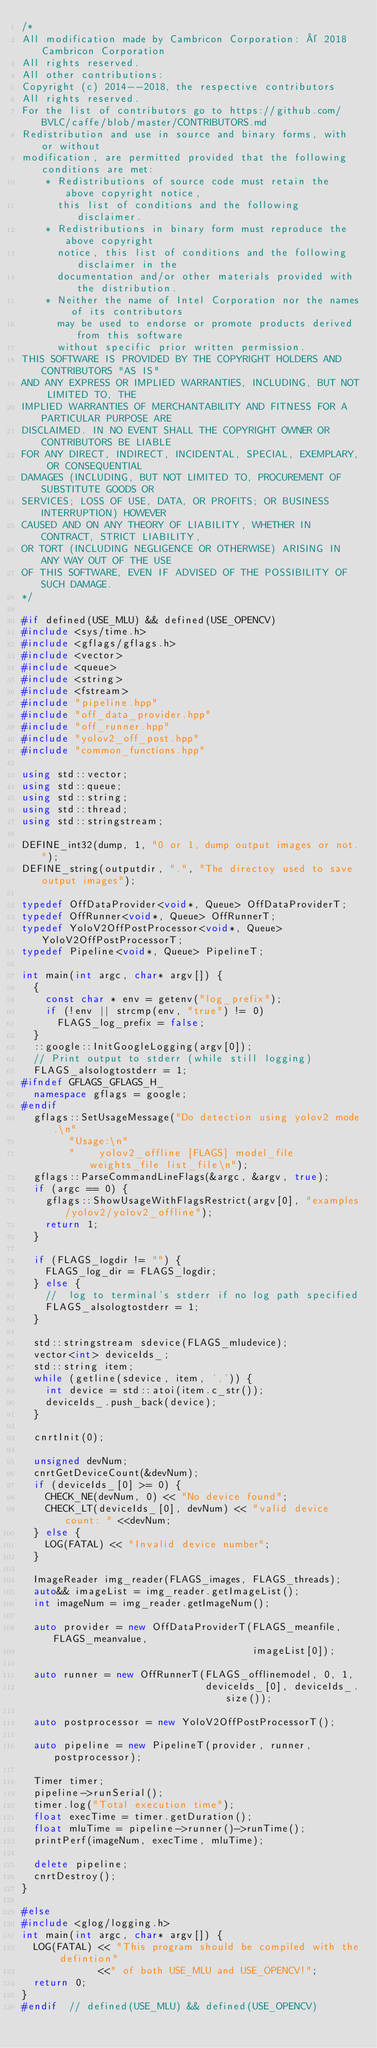<code> <loc_0><loc_0><loc_500><loc_500><_C++_>/*
All modification made by Cambricon Corporation: © 2018 Cambricon Corporation
All rights reserved.
All other contributions:
Copyright (c) 2014--2018, the respective contributors
All rights reserved.
For the list of contributors go to https://github.com/BVLC/caffe/blob/master/CONTRIBUTORS.md
Redistribution and use in source and binary forms, with or without
modification, are permitted provided that the following conditions are met:
    * Redistributions of source code must retain the above copyright notice,
      this list of conditions and the following disclaimer.
    * Redistributions in binary form must reproduce the above copyright
      notice, this list of conditions and the following disclaimer in the
      documentation and/or other materials provided with the distribution.
    * Neither the name of Intel Corporation nor the names of its contributors
      may be used to endorse or promote products derived from this software
      without specific prior written permission.
THIS SOFTWARE IS PROVIDED BY THE COPYRIGHT HOLDERS AND CONTRIBUTORS "AS IS"
AND ANY EXPRESS OR IMPLIED WARRANTIES, INCLUDING, BUT NOT LIMITED TO, THE
IMPLIED WARRANTIES OF MERCHANTABILITY AND FITNESS FOR A PARTICULAR PURPOSE ARE
DISCLAIMED. IN NO EVENT SHALL THE COPYRIGHT OWNER OR CONTRIBUTORS BE LIABLE
FOR ANY DIRECT, INDIRECT, INCIDENTAL, SPECIAL, EXEMPLARY, OR CONSEQUENTIAL
DAMAGES (INCLUDING, BUT NOT LIMITED TO, PROCUREMENT OF SUBSTITUTE GOODS OR
SERVICES; LOSS OF USE, DATA, OR PROFITS; OR BUSINESS INTERRUPTION) HOWEVER
CAUSED AND ON ANY THEORY OF LIABILITY, WHETHER IN CONTRACT, STRICT LIABILITY,
OR TORT (INCLUDING NEGLIGENCE OR OTHERWISE) ARISING IN ANY WAY OUT OF THE USE
OF THIS SOFTWARE, EVEN IF ADVISED OF THE POSSIBILITY OF SUCH DAMAGE.
*/

#if defined(USE_MLU) && defined(USE_OPENCV)
#include <sys/time.h>
#include <gflags/gflags.h>
#include <vector>
#include <queue>
#include <string>
#include <fstream>
#include "pipeline.hpp"
#include "off_data_provider.hpp"
#include "off_runner.hpp"
#include "yolov2_off_post.hpp"
#include "common_functions.hpp"

using std::vector;
using std::queue;
using std::string;
using std::thread;
using std::stringstream;

DEFINE_int32(dump, 1, "0 or 1, dump output images or not.");
DEFINE_string(outputdir, ".", "The directoy used to save output images");

typedef OffDataProvider<void*, Queue> OffDataProviderT;
typedef OffRunner<void*, Queue> OffRunnerT;
typedef YoloV2OffPostProcessor<void*, Queue> YoloV2OffPostProcessorT;
typedef Pipeline<void*, Queue> PipelineT;

int main(int argc, char* argv[]) {
  {
    const char * env = getenv("log_prefix");
    if (!env || strcmp(env, "true") != 0)
      FLAGS_log_prefix = false;
  }
  ::google::InitGoogleLogging(argv[0]);
  // Print output to stderr (while still logging)
  FLAGS_alsologtostderr = 1;
#ifndef GFLAGS_GFLAGS_H_
  namespace gflags = google;
#endif
  gflags::SetUsageMessage("Do detection using yolov2 mode.\n"
        "Usage:\n"
        "    yolov2_offline [FLAGS] model_file weights_file list_file\n");
  gflags::ParseCommandLineFlags(&argc, &argv, true);
  if (argc == 0) {
    gflags::ShowUsageWithFlagsRestrict(argv[0], "examples/yolov2/yolov2_offline");
    return 1;
  }

  if (FLAGS_logdir != "") {
    FLAGS_log_dir = FLAGS_logdir;
  } else {
    //  log to terminal's stderr if no log path specified
    FLAGS_alsologtostderr = 1;
  }

  std::stringstream sdevice(FLAGS_mludevice);
  vector<int> deviceIds_;
  std::string item;
  while (getline(sdevice, item, ',')) {
    int device = std::atoi(item.c_str());
    deviceIds_.push_back(device);
  }

  cnrtInit(0);

  unsigned devNum;
  cnrtGetDeviceCount(&devNum);
  if (deviceIds_[0] >= 0) {
    CHECK_NE(devNum, 0) << "No device found";
    CHECK_LT(deviceIds_[0], devNum) << "valid device count: " <<devNum;
  } else {
    LOG(FATAL) << "Invalid device number";
  }

  ImageReader img_reader(FLAGS_images, FLAGS_threads);
  auto&& imageList = img_reader.getImageList();
  int imageNum = img_reader.getImageNum();

  auto provider = new OffDataProviderT(FLAGS_meanfile, FLAGS_meanvalue,
                                       imageList[0]);

  auto runner = new OffRunnerT(FLAGS_offlinemodel, 0, 1,
                               deviceIds_[0], deviceIds_.size());

  auto postprocessor = new YoloV2OffPostProcessorT();

  auto pipeline = new PipelineT(provider, runner, postprocessor);

  Timer timer;
  pipeline->runSerial();
  timer.log("Total execution time");
  float execTime = timer.getDuration();
  float mluTime = pipeline->runner()->runTime();
  printPerf(imageNum, execTime, mluTime);

  delete pipeline;
  cnrtDestroy();
}

#else
#include <glog/logging.h>
int main(int argc, char* argv[]) {
  LOG(FATAL) << "This program should be compiled with the defintion"
             <<" of both USE_MLU and USE_OPENCV!";
  return 0;
}
#endif  // defined(USE_MLU) && defined(USE_OPENCV)
</code> 